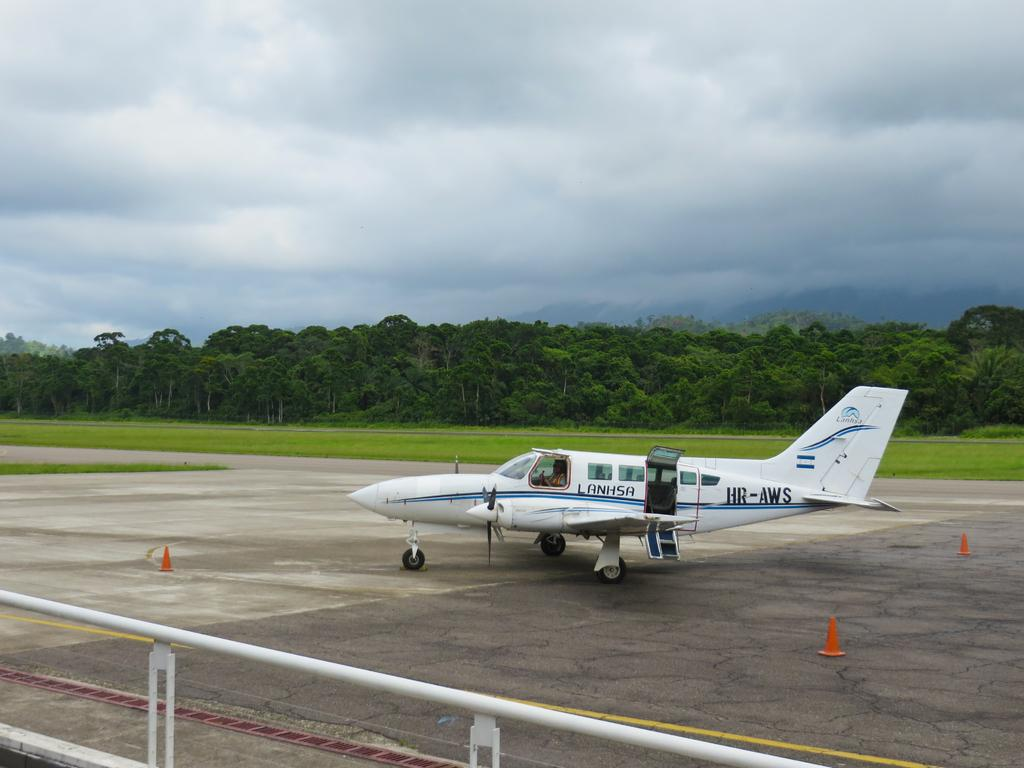Provide a one-sentence caption for the provided image. A small passenger plane labeled Lanhsha sits on a runway. 